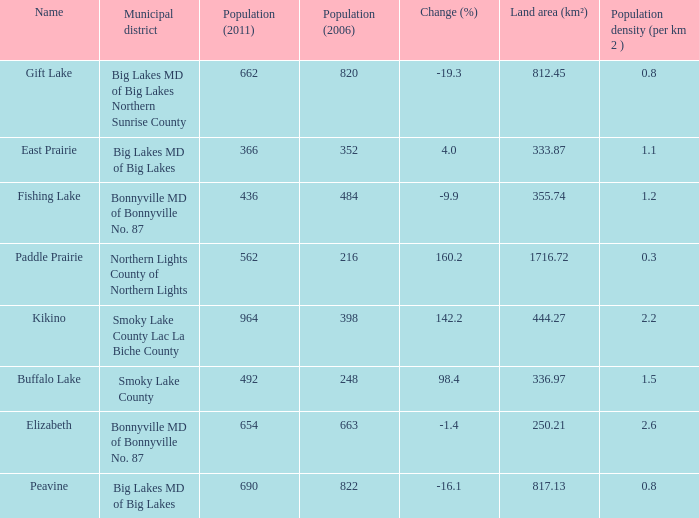What place is there a change of -19.3? 1.0. 